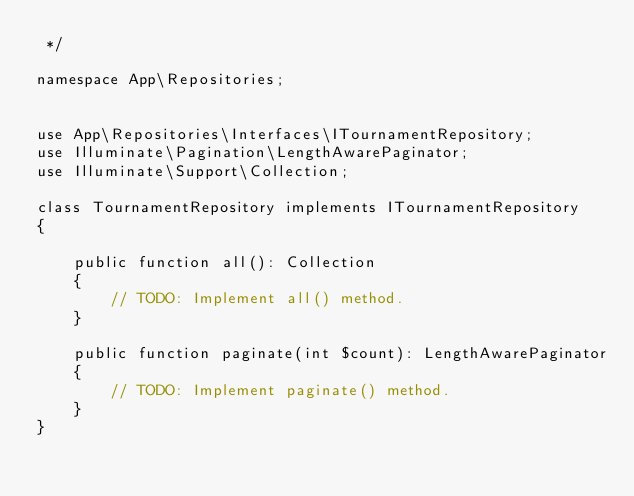Convert code to text. <code><loc_0><loc_0><loc_500><loc_500><_PHP_> */

namespace App\Repositories;


use App\Repositories\Interfaces\ITournamentRepository;
use Illuminate\Pagination\LengthAwarePaginator;
use Illuminate\Support\Collection;

class TournamentRepository implements ITournamentRepository
{

    public function all(): Collection
    {
        // TODO: Implement all() method.
    }

    public function paginate(int $count): LengthAwarePaginator
    {
        // TODO: Implement paginate() method.
    }
}</code> 